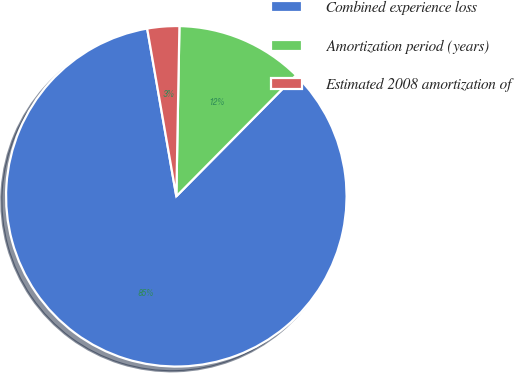Convert chart. <chart><loc_0><loc_0><loc_500><loc_500><pie_chart><fcel>Combined experience loss<fcel>Amortization period (years)<fcel>Estimated 2008 amortization of<nl><fcel>84.85%<fcel>12.12%<fcel>3.03%<nl></chart> 